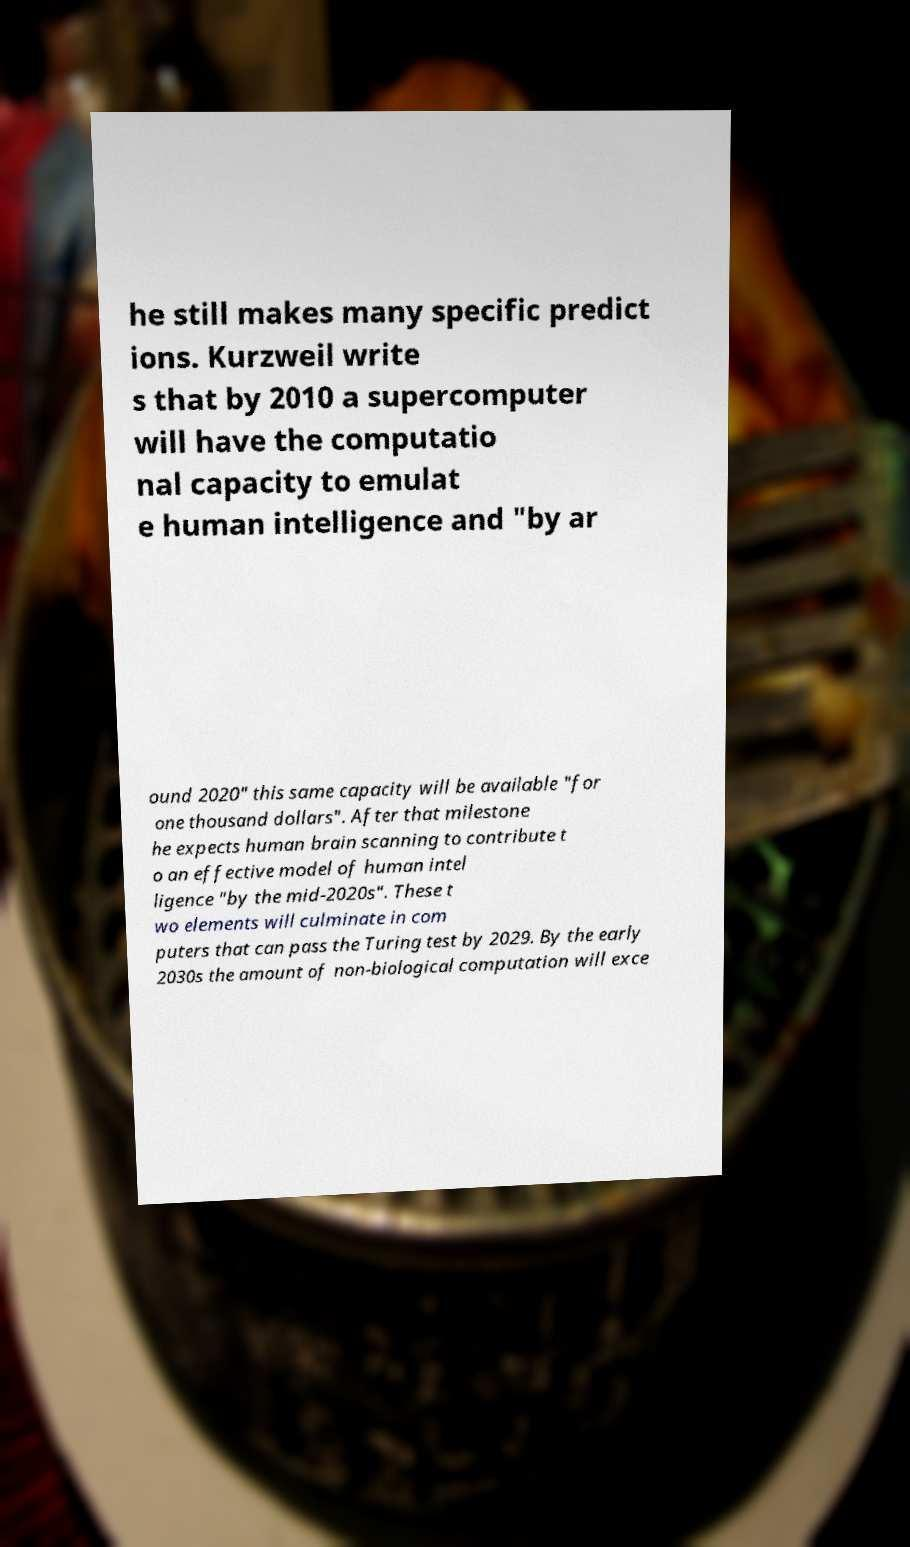There's text embedded in this image that I need extracted. Can you transcribe it verbatim? he still makes many specific predict ions. Kurzweil write s that by 2010 a supercomputer will have the computatio nal capacity to emulat e human intelligence and "by ar ound 2020" this same capacity will be available "for one thousand dollars". After that milestone he expects human brain scanning to contribute t o an effective model of human intel ligence "by the mid-2020s". These t wo elements will culminate in com puters that can pass the Turing test by 2029. By the early 2030s the amount of non-biological computation will exce 